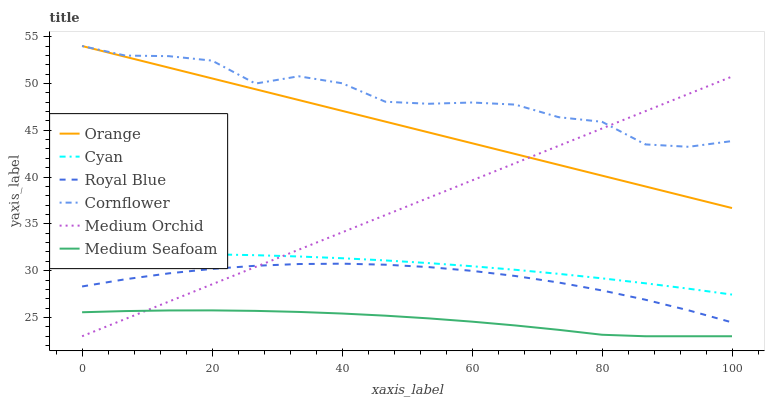Does Medium Seafoam have the minimum area under the curve?
Answer yes or no. Yes. Does Cornflower have the maximum area under the curve?
Answer yes or no. Yes. Does Medium Orchid have the minimum area under the curve?
Answer yes or no. No. Does Medium Orchid have the maximum area under the curve?
Answer yes or no. No. Is Medium Orchid the smoothest?
Answer yes or no. Yes. Is Cornflower the roughest?
Answer yes or no. Yes. Is Royal Blue the smoothest?
Answer yes or no. No. Is Royal Blue the roughest?
Answer yes or no. No. Does Medium Orchid have the lowest value?
Answer yes or no. Yes. Does Royal Blue have the lowest value?
Answer yes or no. No. Does Orange have the highest value?
Answer yes or no. Yes. Does Medium Orchid have the highest value?
Answer yes or no. No. Is Medium Seafoam less than Orange?
Answer yes or no. Yes. Is Cornflower greater than Cyan?
Answer yes or no. Yes. Does Medium Orchid intersect Cyan?
Answer yes or no. Yes. Is Medium Orchid less than Cyan?
Answer yes or no. No. Is Medium Orchid greater than Cyan?
Answer yes or no. No. Does Medium Seafoam intersect Orange?
Answer yes or no. No. 